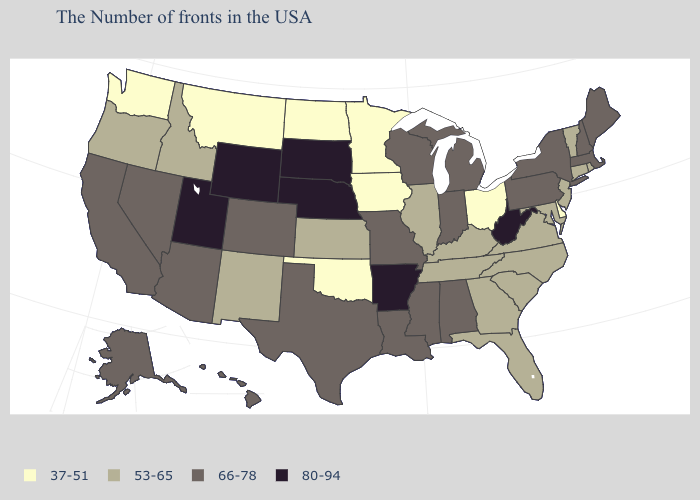Which states have the highest value in the USA?
Quick response, please. West Virginia, Arkansas, Nebraska, South Dakota, Wyoming, Utah. Which states have the highest value in the USA?
Quick response, please. West Virginia, Arkansas, Nebraska, South Dakota, Wyoming, Utah. Does Pennsylvania have the highest value in the Northeast?
Short answer required. Yes. What is the value of South Dakota?
Concise answer only. 80-94. How many symbols are there in the legend?
Concise answer only. 4. Does Hawaii have the highest value in the USA?
Keep it brief. No. Name the states that have a value in the range 80-94?
Short answer required. West Virginia, Arkansas, Nebraska, South Dakota, Wyoming, Utah. What is the value of Illinois?
Be succinct. 53-65. What is the lowest value in states that border West Virginia?
Give a very brief answer. 37-51. Which states have the lowest value in the USA?
Quick response, please. Delaware, Ohio, Minnesota, Iowa, Oklahoma, North Dakota, Montana, Washington. Name the states that have a value in the range 37-51?
Give a very brief answer. Delaware, Ohio, Minnesota, Iowa, Oklahoma, North Dakota, Montana, Washington. Is the legend a continuous bar?
Be succinct. No. Among the states that border Iowa , which have the highest value?
Quick response, please. Nebraska, South Dakota. What is the value of Virginia?
Concise answer only. 53-65. Among the states that border Ohio , which have the lowest value?
Be succinct. Kentucky. 